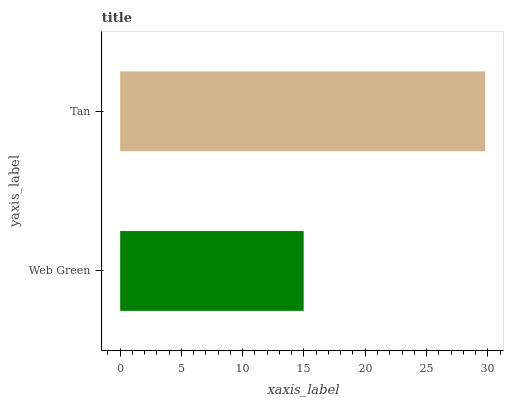Is Web Green the minimum?
Answer yes or no. Yes. Is Tan the maximum?
Answer yes or no. Yes. Is Tan the minimum?
Answer yes or no. No. Is Tan greater than Web Green?
Answer yes or no. Yes. Is Web Green less than Tan?
Answer yes or no. Yes. Is Web Green greater than Tan?
Answer yes or no. No. Is Tan less than Web Green?
Answer yes or no. No. Is Tan the high median?
Answer yes or no. Yes. Is Web Green the low median?
Answer yes or no. Yes. Is Web Green the high median?
Answer yes or no. No. Is Tan the low median?
Answer yes or no. No. 